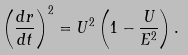<formula> <loc_0><loc_0><loc_500><loc_500>\left ( \frac { d r } { d t } \right ) ^ { 2 } = U ^ { 2 } \left ( 1 - \frac { U } { E ^ { 2 } } \right ) .</formula> 